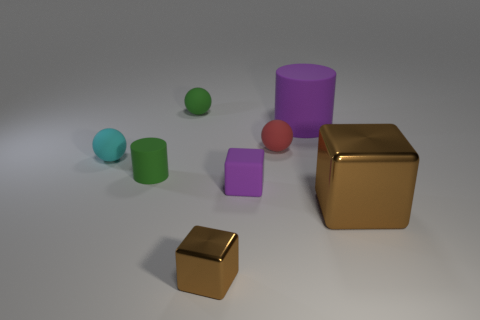Subtract all yellow balls. How many brown cubes are left? 2 Subtract all tiny cyan rubber balls. How many balls are left? 2 Add 1 big green matte objects. How many objects exist? 9 Subtract all cubes. How many objects are left? 5 Subtract 0 green blocks. How many objects are left? 8 Subtract all blue spheres. Subtract all brown cylinders. How many spheres are left? 3 Subtract all brown metal things. Subtract all small objects. How many objects are left? 0 Add 7 large things. How many large things are left? 9 Add 6 small blue blocks. How many small blue blocks exist? 6 